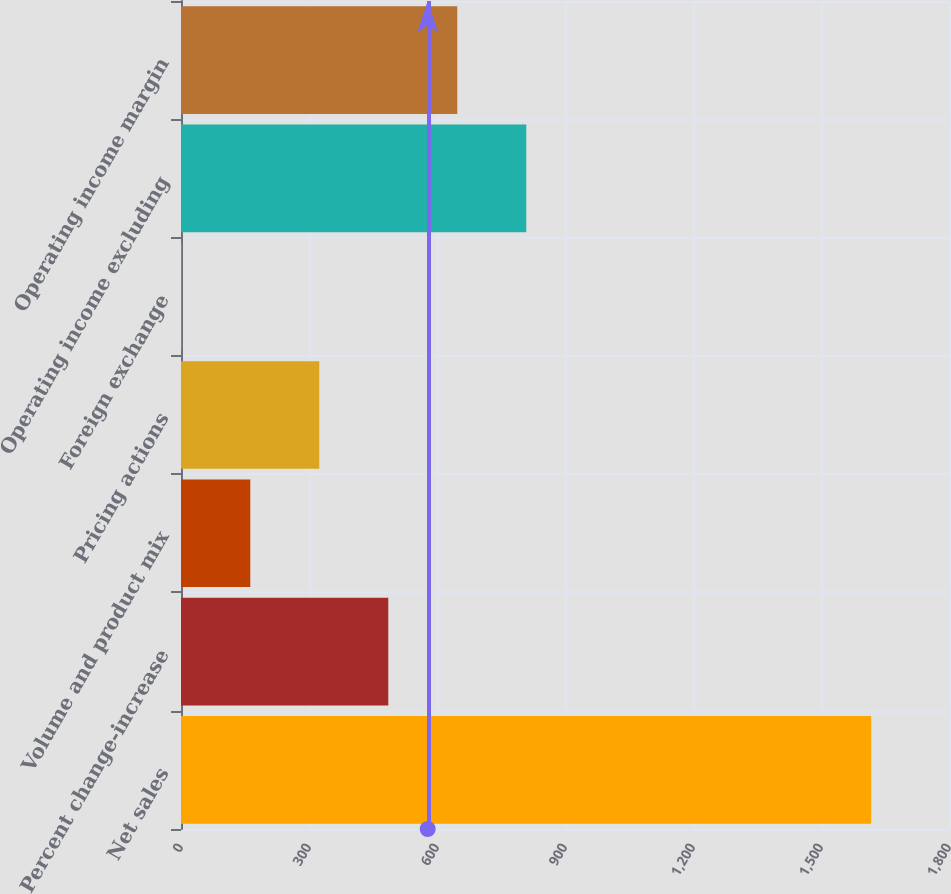Convert chart to OTSL. <chart><loc_0><loc_0><loc_500><loc_500><bar_chart><fcel>Net sales<fcel>Percent change-increase<fcel>Volume and product mix<fcel>Pricing actions<fcel>Foreign exchange<fcel>Operating income excluding<fcel>Operating income margin<nl><fcel>1617.7<fcel>485.8<fcel>162.4<fcel>324.1<fcel>0.7<fcel>809.2<fcel>647.5<nl></chart> 